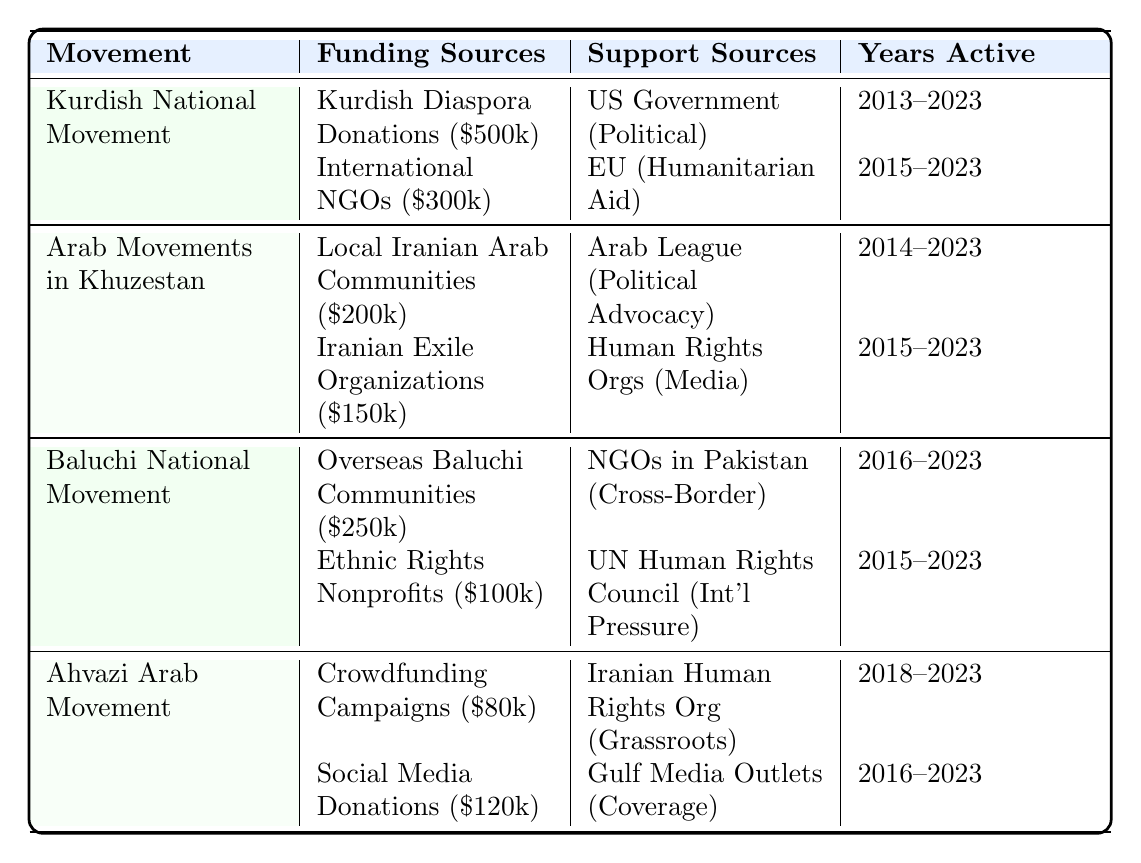What is the total estimated funding for the Kurdish National Movement? The funding sources for the Kurdish National Movement are Kurdish Diaspora Donations ($500k) and International NGOs ($300k). Adding these amounts gives $500k + $300k = $800k.
Answer: $800,000 Which movement received support from the United States Government? The table shows that the Kurdish National Movement received support from the United States Government under the category of Political Support.
Answer: Kurdish National Movement How much funding did the Arab Movements in Khuzestan receive from Iranian Exile Organizations? According to the table, the funding from Iranian Exile Organizations for the Arab Movements in Khuzestan is estimated at $150k.
Answer: $150,000 What is the total funding for the Ahvazi Arab Movement? The total funding for the Ahvazi Arab Movement comes from Crowdfunding Campaigns ($80k) and Social Media Donations ($120k). Adding these gives $80k + $120k = $200k.
Answer: $200,000 Did the Baluchi National Movement have any funding sources before 2018? The Baluchi National Movement's funding sources started in 2016 (Overseas Baluchi Communities) and 2018 (Ethnic Rights Nonprofits). Thus, funding is recorded starting from 2016, which is before 2018.
Answer: Yes Which movement had the least estimated funding from support sources? The Ahvazi Arab Movement has two support sources: Iranian Human Rights Organization and Media Outlets in the Gulf. The table does not list estimated monetary values for these supports, so we need to focus on the funding sources instead. Ahvazi Arab Movement's total funding is $200k which is less than other movements.
Answer: Ahvazi Arab Movement What is the average estimated funding across all movements mentioned in the table? The total funding for all movements is $800k (Kurdish) + $350k (Arab Movements in Khuzestan) + $350k (Baluchi) + $200k (Ahvazi) = $1,700k. There are 4 movements, so the average funding is $1,700k / 4 = $425k.
Answer: $425,000 Which movement has the highest estimated funding from their respective funding sources? The funding amounts for each movement are as follows: Kurdish National Movement ($800k), Arab Movements in Khuzestan ($350k), Baluchi National Movement ($350k), and Ahvazi Arab Movement ($200k). Therefore, the Kurdish National Movement has the highest estimated funding from their sources.
Answer: Kurdish National Movement What types of support do the Kurdish National Movement and the Baluchi National Movement receive? The Kurdish National Movement receives Political Support from the US Government and Humanitarian Aid from the EU. The Baluchi National Movement receives Cross-Border Support from NGOs in Pakistan and International Pressure from the UN Human Rights Council.
Answer: Political Support and Humanitarian Aid; Cross-Border Support and International Pressure Is there any overlap in the years active for the funding sources between the Baluchi National Movement and Arab Movements in Khuzestan? The Baluchi National Movement is active from 2016 to 2023, while the Arab Movements in Khuzestan are active from 2014 to 2023. Both movements overlap in their active years from 2016 to 2023.
Answer: Yes 